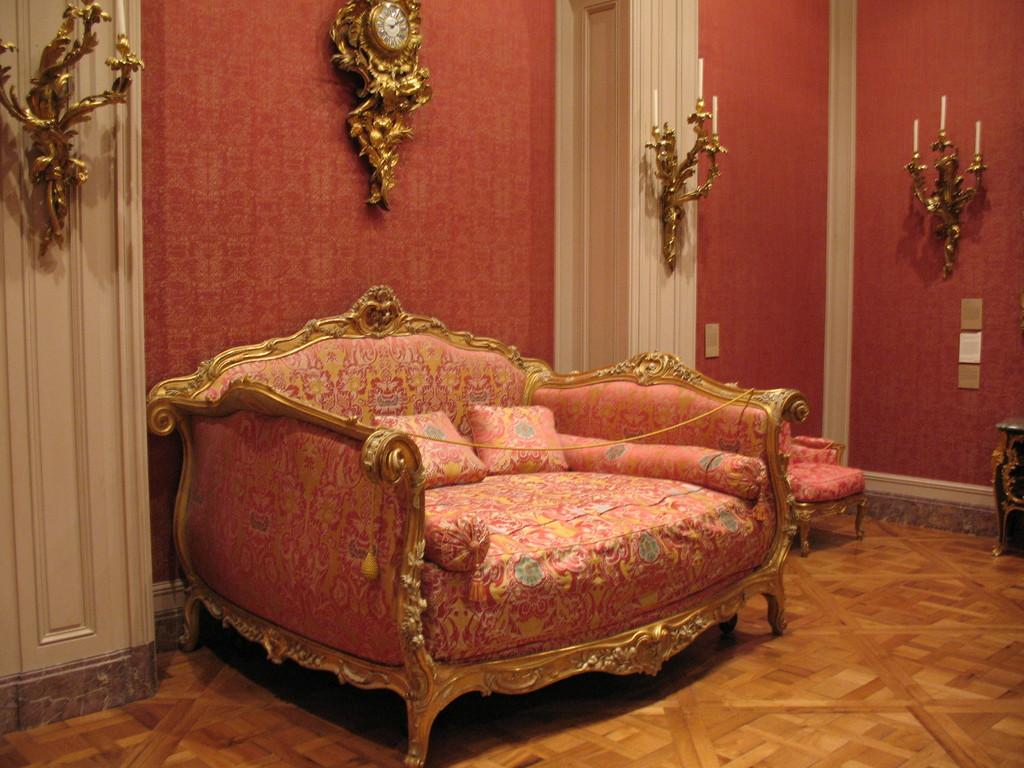What type of furniture is in the image? There is a sofa and a chair in the image. What is on the sofa? There are pillows on the sofa. What can be seen in the background of the image? There is a wall and a door in the background of the image. What is the surface that the furniture is placed on? There is a floor visible in the image. What type of polish is being applied to the wall in the image? There is no indication of any polish being applied to the wall in the image. 